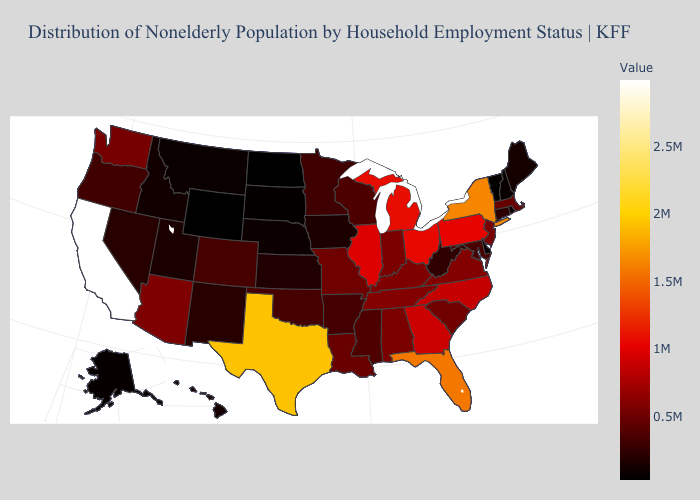Among the states that border Alabama , does Mississippi have the lowest value?
Give a very brief answer. Yes. Among the states that border Kansas , which have the lowest value?
Short answer required. Nebraska. Which states have the lowest value in the USA?
Short answer required. Wyoming. Among the states that border Maine , which have the highest value?
Concise answer only. New Hampshire. Does New York have the highest value in the Northeast?
Concise answer only. Yes. Is the legend a continuous bar?
Write a very short answer. Yes. Which states have the lowest value in the Northeast?
Write a very short answer. Vermont. 